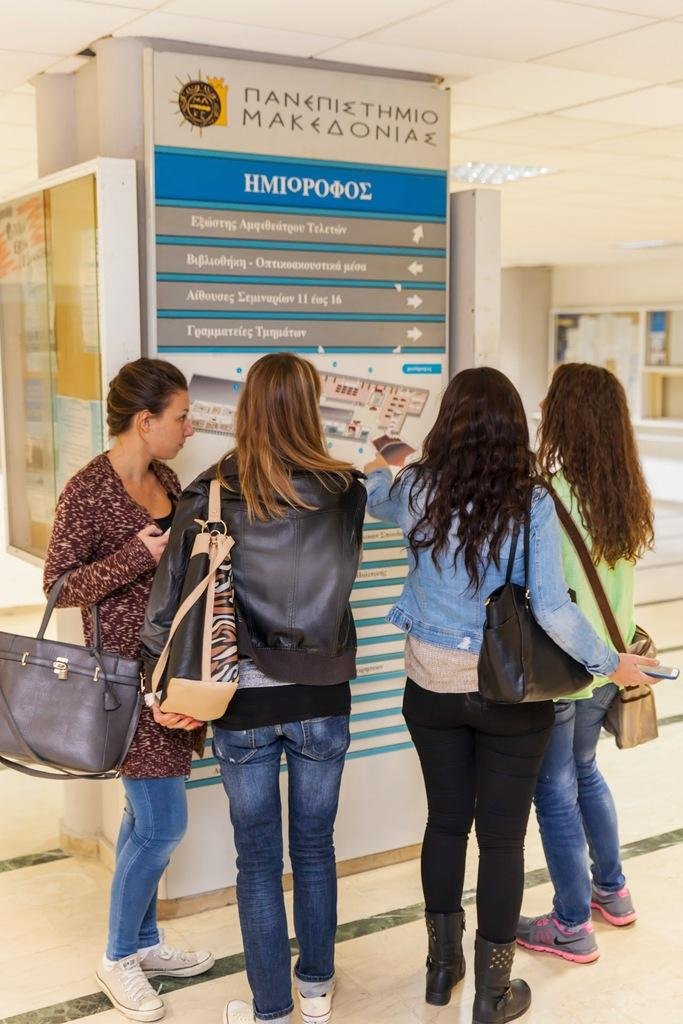What is the main subject of the image? The main subject of the image is a group of people. What are the people in the image doing? The people are standing in the image. What are the people wearing that is visible in the image? The people are wearing bags in the image. What type of structure is visible in the image? There is a roof visible in the image. How loud is the action taking place in the image? The image does not depict any action or sound, so it is not possible to determine the volume or loudness of the scene. 